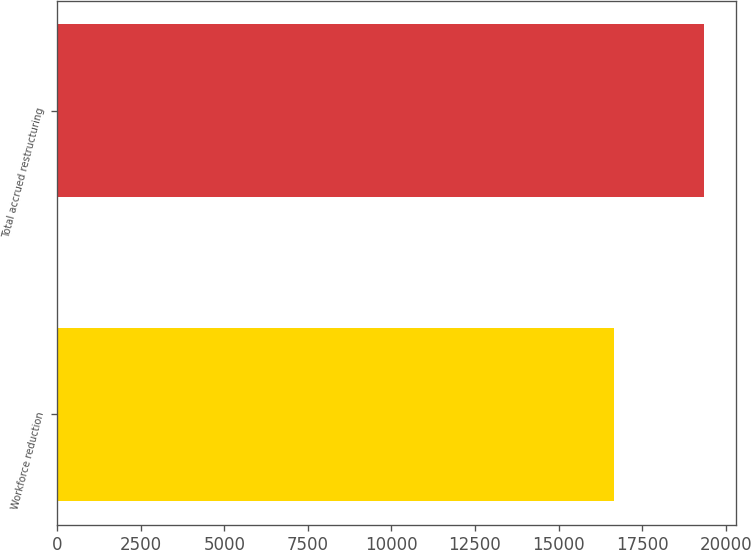<chart> <loc_0><loc_0><loc_500><loc_500><bar_chart><fcel>Workforce reduction<fcel>Total accrued restructuring<nl><fcel>16661<fcel>19347<nl></chart> 